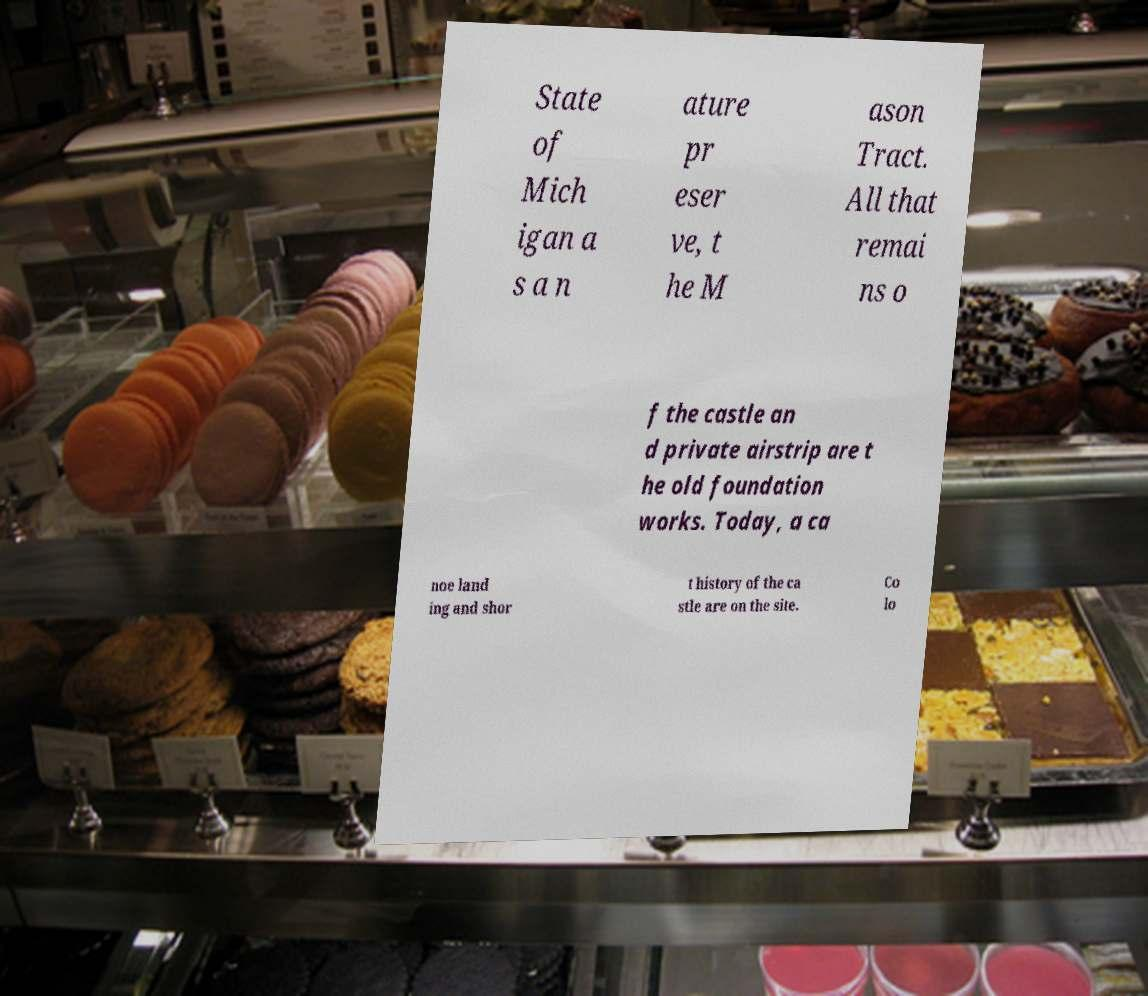Please read and relay the text visible in this image. What does it say? State of Mich igan a s a n ature pr eser ve, t he M ason Tract. All that remai ns o f the castle an d private airstrip are t he old foundation works. Today, a ca noe land ing and shor t history of the ca stle are on the site. Co lo 